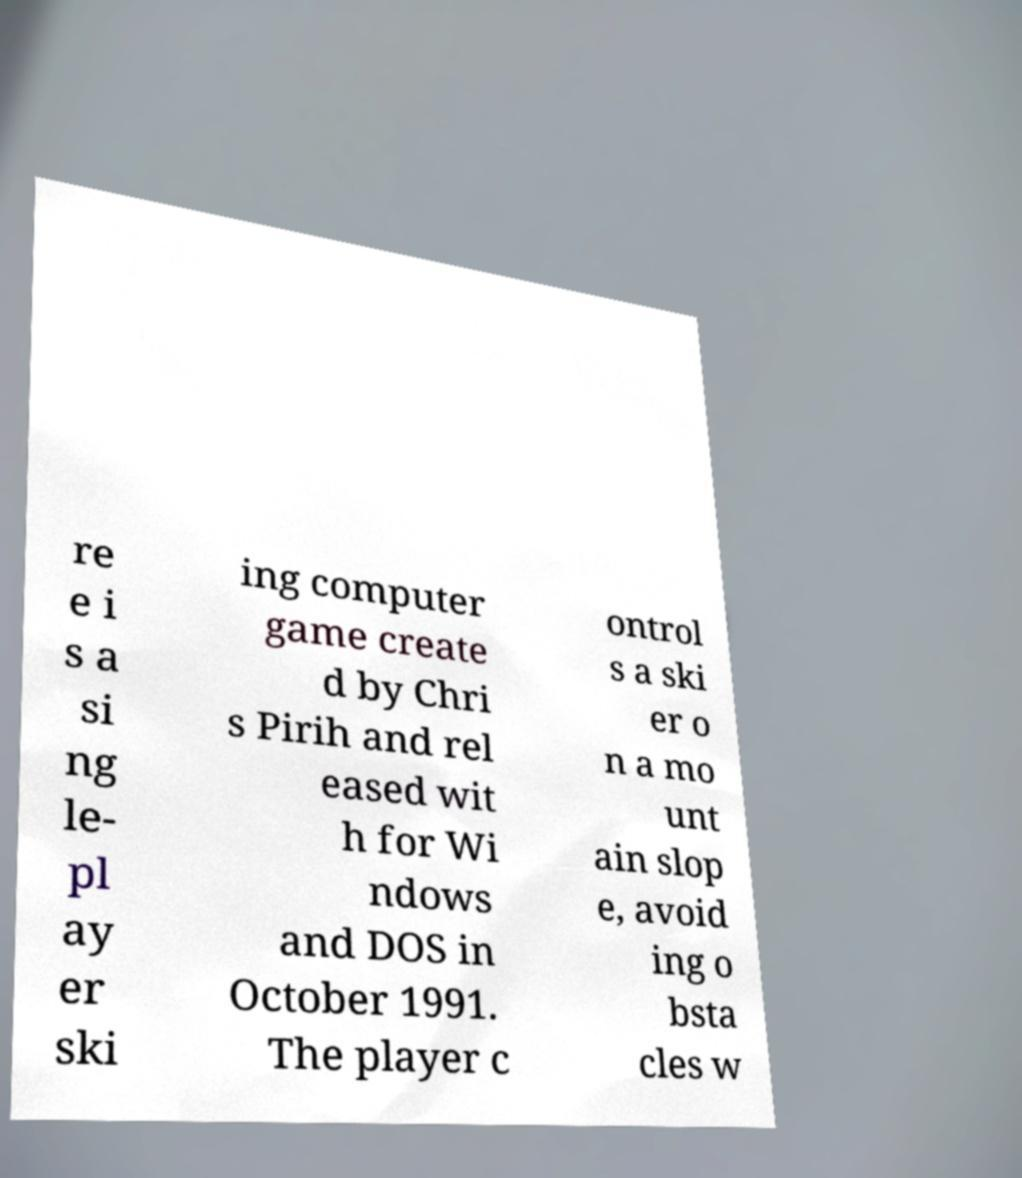Please read and relay the text visible in this image. What does it say? re e i s a si ng le- pl ay er ski ing computer game create d by Chri s Pirih and rel eased wit h for Wi ndows and DOS in October 1991. The player c ontrol s a ski er o n a mo unt ain slop e, avoid ing o bsta cles w 